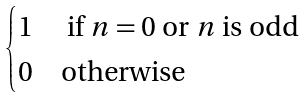<formula> <loc_0><loc_0><loc_500><loc_500>\begin{cases} 1 & \text { if } n = 0 \text { or } n \text { is odd} \\ 0 & \text {otherwise} \end{cases}</formula> 